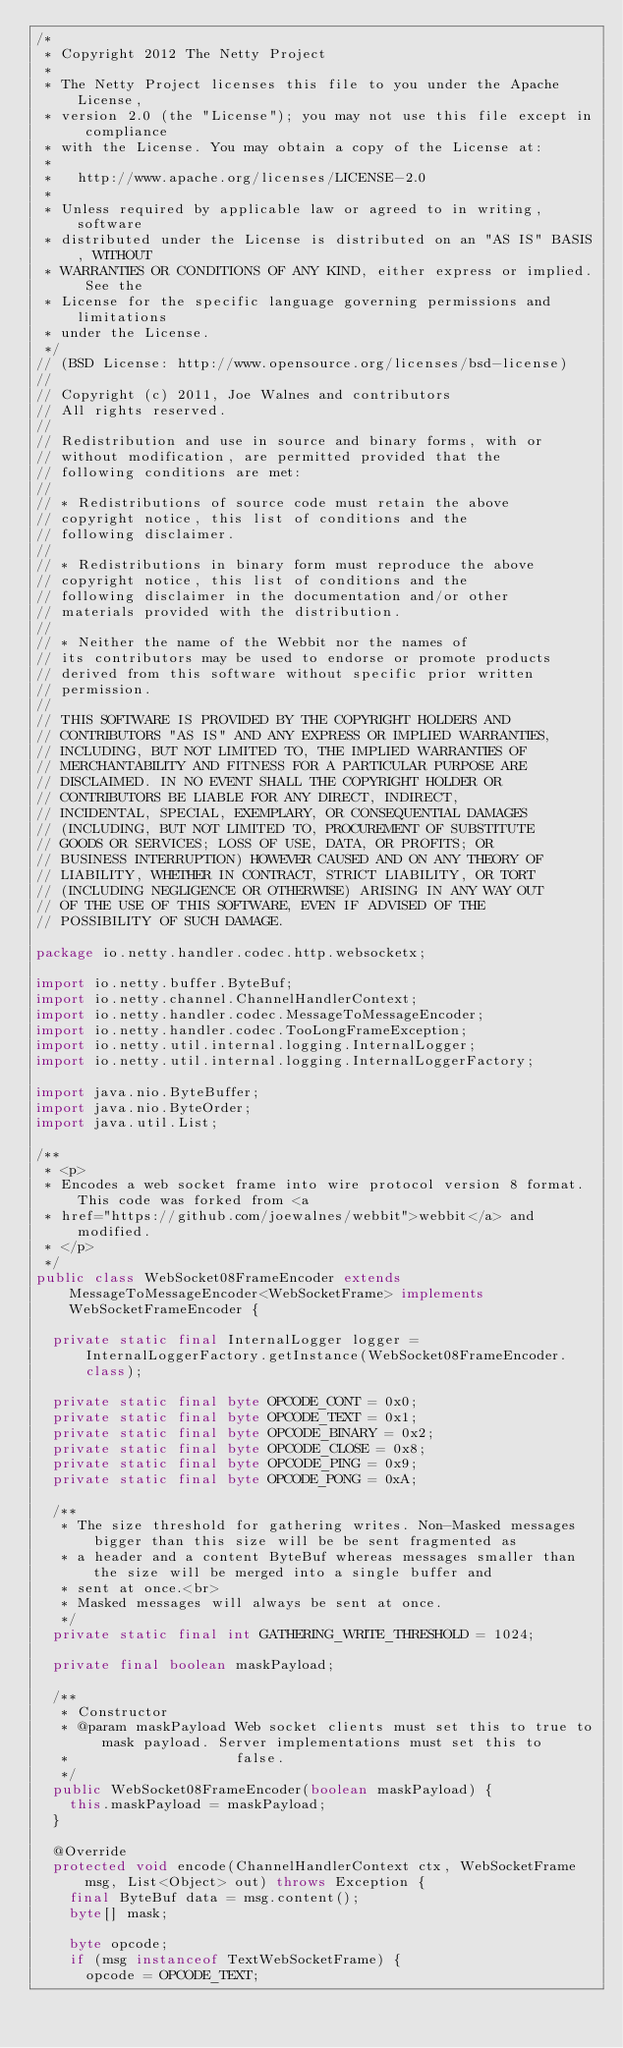<code> <loc_0><loc_0><loc_500><loc_500><_Java_>/*
 * Copyright 2012 The Netty Project
 *
 * The Netty Project licenses this file to you under the Apache License,
 * version 2.0 (the "License"); you may not use this file except in compliance
 * with the License. You may obtain a copy of the License at:
 *
 *   http://www.apache.org/licenses/LICENSE-2.0
 *
 * Unless required by applicable law or agreed to in writing, software
 * distributed under the License is distributed on an "AS IS" BASIS, WITHOUT
 * WARRANTIES OR CONDITIONS OF ANY KIND, either express or implied. See the
 * License for the specific language governing permissions and limitations
 * under the License.
 */
// (BSD License: http://www.opensource.org/licenses/bsd-license)
//
// Copyright (c) 2011, Joe Walnes and contributors
// All rights reserved.
//
// Redistribution and use in source and binary forms, with or
// without modification, are permitted provided that the
// following conditions are met:
//
// * Redistributions of source code must retain the above
// copyright notice, this list of conditions and the
// following disclaimer.
//
// * Redistributions in binary form must reproduce the above
// copyright notice, this list of conditions and the
// following disclaimer in the documentation and/or other
// materials provided with the distribution.
//
// * Neither the name of the Webbit nor the names of
// its contributors may be used to endorse or promote products
// derived from this software without specific prior written
// permission.
//
// THIS SOFTWARE IS PROVIDED BY THE COPYRIGHT HOLDERS AND
// CONTRIBUTORS "AS IS" AND ANY EXPRESS OR IMPLIED WARRANTIES,
// INCLUDING, BUT NOT LIMITED TO, THE IMPLIED WARRANTIES OF
// MERCHANTABILITY AND FITNESS FOR A PARTICULAR PURPOSE ARE
// DISCLAIMED. IN NO EVENT SHALL THE COPYRIGHT HOLDER OR
// CONTRIBUTORS BE LIABLE FOR ANY DIRECT, INDIRECT,
// INCIDENTAL, SPECIAL, EXEMPLARY, OR CONSEQUENTIAL DAMAGES
// (INCLUDING, BUT NOT LIMITED TO, PROCUREMENT OF SUBSTITUTE
// GOODS OR SERVICES; LOSS OF USE, DATA, OR PROFITS; OR
// BUSINESS INTERRUPTION) HOWEVER CAUSED AND ON ANY THEORY OF
// LIABILITY, WHETHER IN CONTRACT, STRICT LIABILITY, OR TORT
// (INCLUDING NEGLIGENCE OR OTHERWISE) ARISING IN ANY WAY OUT
// OF THE USE OF THIS SOFTWARE, EVEN IF ADVISED OF THE
// POSSIBILITY OF SUCH DAMAGE.

package io.netty.handler.codec.http.websocketx;

import io.netty.buffer.ByteBuf;
import io.netty.channel.ChannelHandlerContext;
import io.netty.handler.codec.MessageToMessageEncoder;
import io.netty.handler.codec.TooLongFrameException;
import io.netty.util.internal.logging.InternalLogger;
import io.netty.util.internal.logging.InternalLoggerFactory;

import java.nio.ByteBuffer;
import java.nio.ByteOrder;
import java.util.List;

/**
 * <p>
 * Encodes a web socket frame into wire protocol version 8 format. This code was forked from <a
 * href="https://github.com/joewalnes/webbit">webbit</a> and modified.
 * </p>
 */
public class WebSocket08FrameEncoder extends MessageToMessageEncoder<WebSocketFrame> implements WebSocketFrameEncoder {

  private static final InternalLogger logger = InternalLoggerFactory.getInstance(WebSocket08FrameEncoder.class);

  private static final byte OPCODE_CONT = 0x0;
  private static final byte OPCODE_TEXT = 0x1;
  private static final byte OPCODE_BINARY = 0x2;
  private static final byte OPCODE_CLOSE = 0x8;
  private static final byte OPCODE_PING = 0x9;
  private static final byte OPCODE_PONG = 0xA;

  /**
   * The size threshold for gathering writes. Non-Masked messages bigger than this size will be be sent fragmented as
   * a header and a content ByteBuf whereas messages smaller than the size will be merged into a single buffer and
   * sent at once.<br>
   * Masked messages will always be sent at once.
   */
  private static final int GATHERING_WRITE_THRESHOLD = 1024;

  private final boolean maskPayload;

  /**
   * Constructor
   * @param maskPayload Web socket clients must set this to true to mask payload. Server implementations must set this to
   *                    false.
   */
  public WebSocket08FrameEncoder(boolean maskPayload) {
    this.maskPayload = maskPayload;
  }

  @Override
  protected void encode(ChannelHandlerContext ctx, WebSocketFrame msg, List<Object> out) throws Exception {
    final ByteBuf data = msg.content();
    byte[] mask;

    byte opcode;
    if (msg instanceof TextWebSocketFrame) {
      opcode = OPCODE_TEXT;</code> 